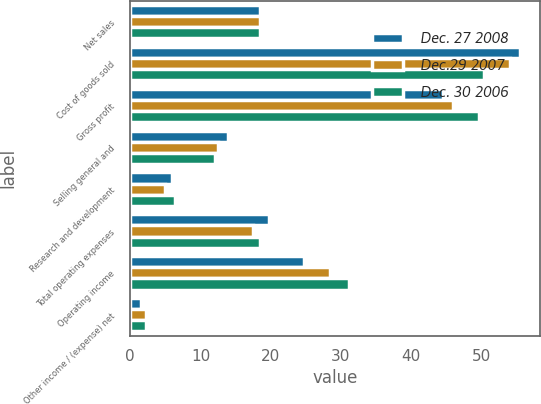<chart> <loc_0><loc_0><loc_500><loc_500><stacked_bar_chart><ecel><fcel>Net sales<fcel>Cost of goods sold<fcel>Gross profit<fcel>Selling general and<fcel>Research and development<fcel>Total operating expenses<fcel>Operating income<fcel>Other income / (expense) net<nl><fcel>Dec. 27 2008<fcel>18.5<fcel>55.5<fcel>44.5<fcel>13.9<fcel>5.9<fcel>19.8<fcel>24.7<fcel>1.5<nl><fcel>Dec.29 2007<fcel>18.5<fcel>54<fcel>46<fcel>12.5<fcel>5<fcel>17.5<fcel>28.5<fcel>2.2<nl><fcel>Dec. 30 2006<fcel>18.5<fcel>50.3<fcel>49.7<fcel>12.1<fcel>6.4<fcel>18.5<fcel>31.2<fcel>2.3<nl></chart> 